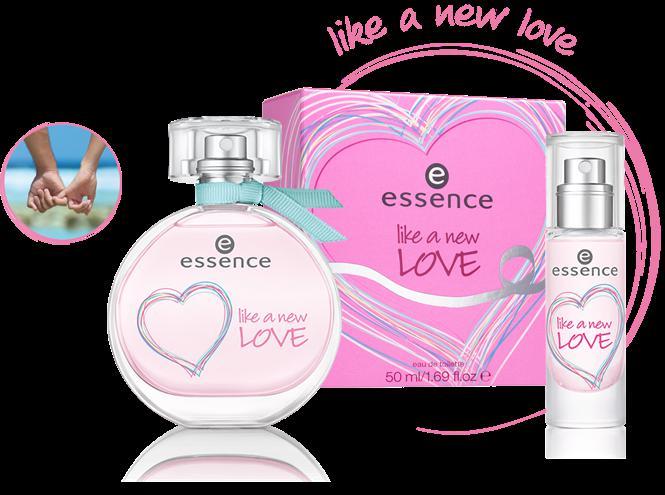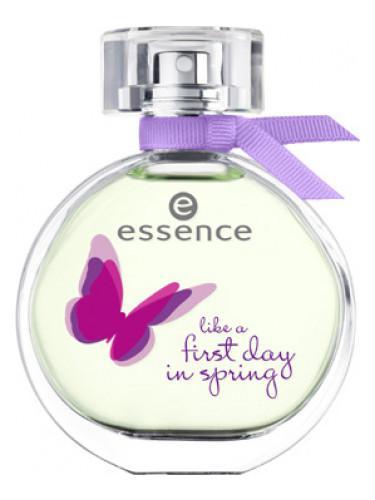The first image is the image on the left, the second image is the image on the right. Analyze the images presented: Is the assertion "there is only one cologne on the right image" valid? Answer yes or no. Yes. 